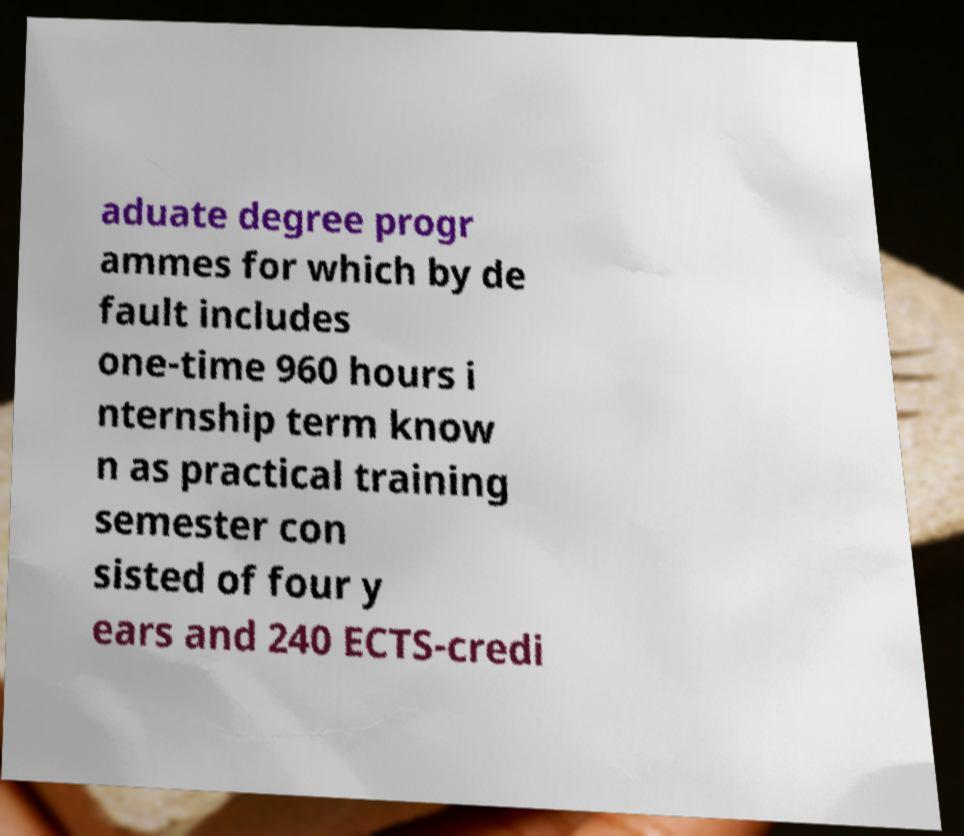Please identify and transcribe the text found in this image. aduate degree progr ammes for which by de fault includes one-time 960 hours i nternship term know n as practical training semester con sisted of four y ears and 240 ECTS-credi 